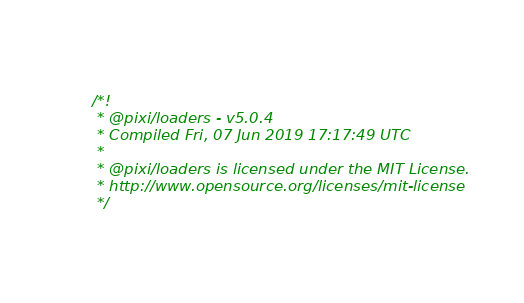Convert code to text. <code><loc_0><loc_0><loc_500><loc_500><_JavaScript_>/*!
 * @pixi/loaders - v5.0.4
 * Compiled Fri, 07 Jun 2019 17:17:49 UTC
 *
 * @pixi/loaders is licensed under the MIT License.
 * http://www.opensource.org/licenses/mit-license
 */</code> 